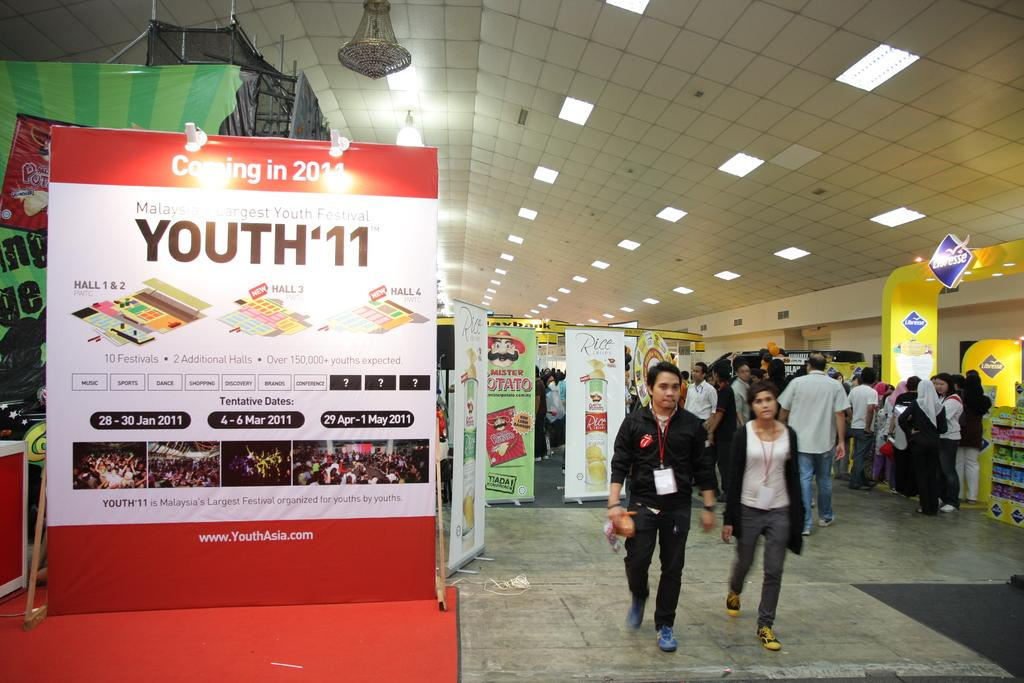<image>
Share a concise interpretation of the image provided. a poster with youth' 11 on the front and people walking by 